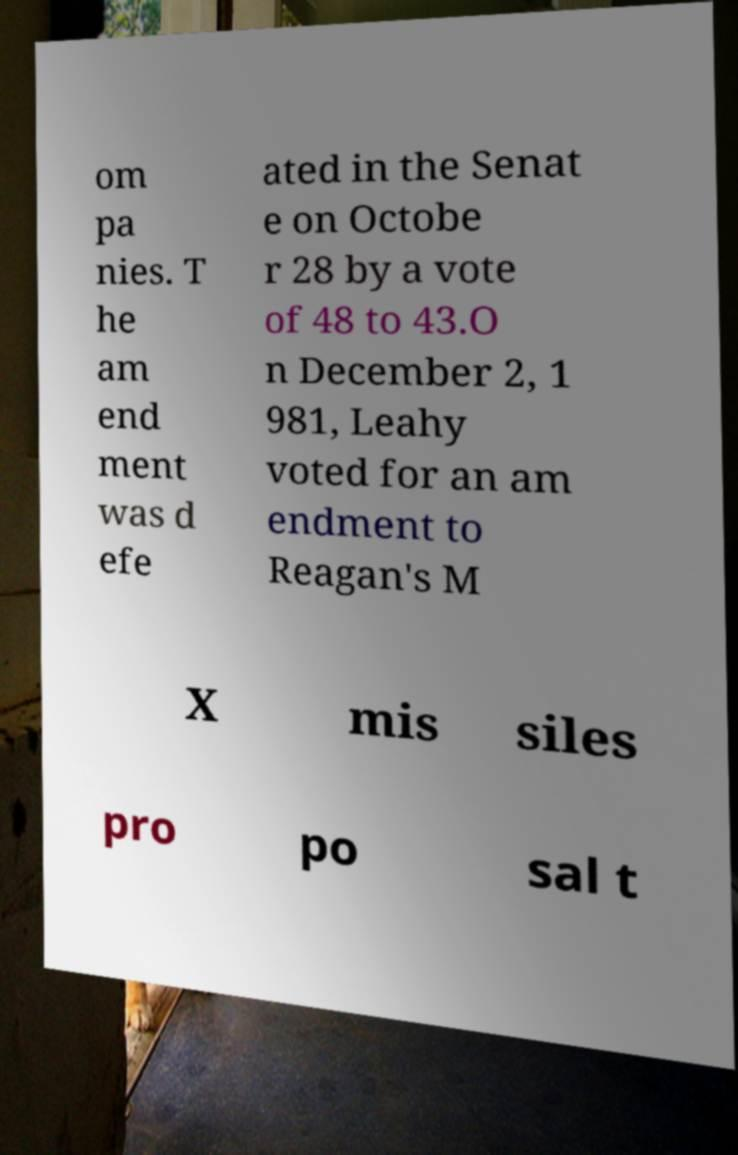For documentation purposes, I need the text within this image transcribed. Could you provide that? om pa nies. T he am end ment was d efe ated in the Senat e on Octobe r 28 by a vote of 48 to 43.O n December 2, 1 981, Leahy voted for an am endment to Reagan's M X mis siles pro po sal t 